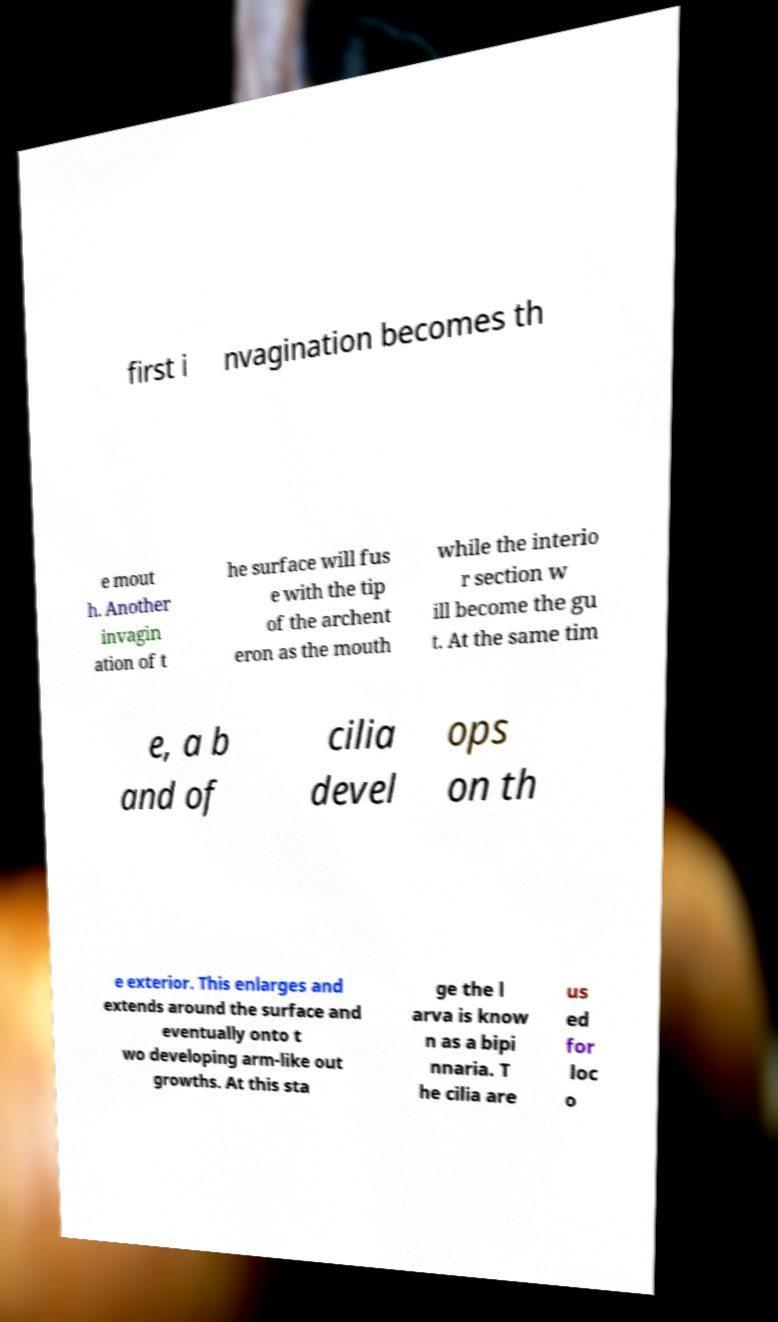I need the written content from this picture converted into text. Can you do that? first i nvagination becomes th e mout h. Another invagin ation of t he surface will fus e with the tip of the archent eron as the mouth while the interio r section w ill become the gu t. At the same tim e, a b and of cilia devel ops on th e exterior. This enlarges and extends around the surface and eventually onto t wo developing arm-like out growths. At this sta ge the l arva is know n as a bipi nnaria. T he cilia are us ed for loc o 